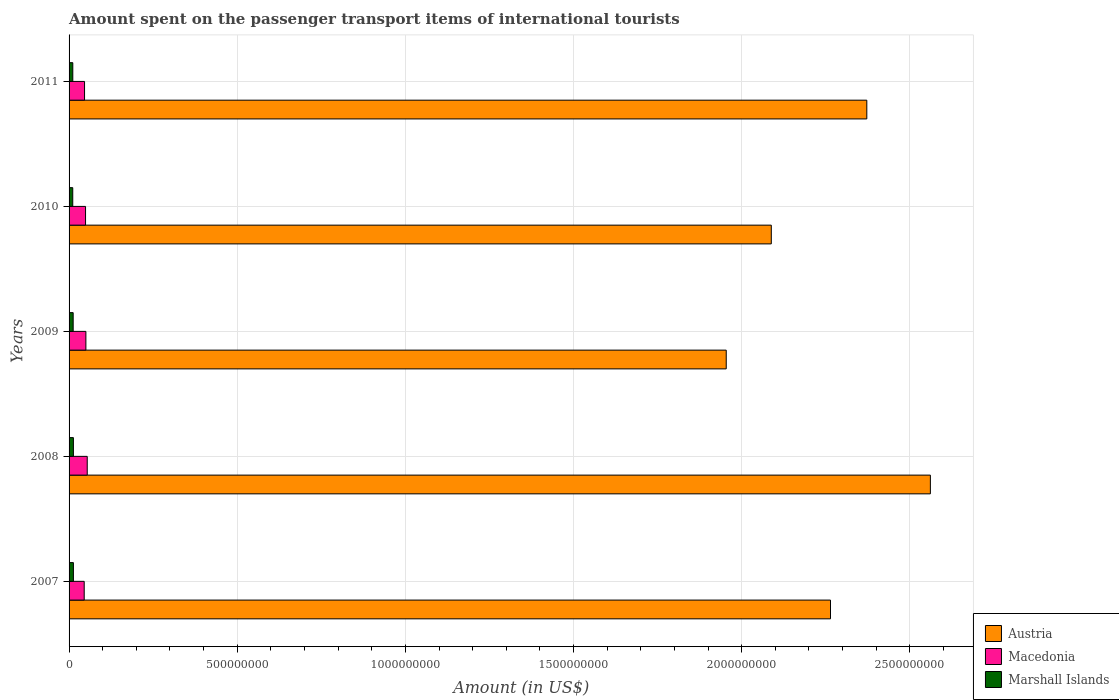How many different coloured bars are there?
Ensure brevity in your answer.  3. Are the number of bars per tick equal to the number of legend labels?
Your response must be concise. Yes. Are the number of bars on each tick of the Y-axis equal?
Make the answer very short. Yes. How many bars are there on the 1st tick from the top?
Make the answer very short. 3. How many bars are there on the 4th tick from the bottom?
Your answer should be compact. 3. What is the label of the 1st group of bars from the top?
Offer a terse response. 2011. What is the amount spent on the passenger transport items of international tourists in Macedonia in 2010?
Offer a very short reply. 4.90e+07. Across all years, what is the maximum amount spent on the passenger transport items of international tourists in Marshall Islands?
Offer a terse response. 1.29e+07. Across all years, what is the minimum amount spent on the passenger transport items of international tourists in Marshall Islands?
Offer a very short reply. 1.09e+07. In which year was the amount spent on the passenger transport items of international tourists in Macedonia maximum?
Provide a succinct answer. 2008. What is the total amount spent on the passenger transport items of international tourists in Austria in the graph?
Your answer should be very brief. 1.12e+1. What is the difference between the amount spent on the passenger transport items of international tourists in Austria in 2007 and that in 2011?
Your answer should be compact. -1.08e+08. What is the difference between the amount spent on the passenger transport items of international tourists in Austria in 2009 and the amount spent on the passenger transport items of international tourists in Macedonia in 2007?
Offer a terse response. 1.91e+09. What is the average amount spent on the passenger transport items of international tourists in Macedonia per year?
Provide a short and direct response. 4.88e+07. In the year 2011, what is the difference between the amount spent on the passenger transport items of international tourists in Macedonia and amount spent on the passenger transport items of international tourists in Marshall Islands?
Your answer should be compact. 3.49e+07. In how many years, is the amount spent on the passenger transport items of international tourists in Marshall Islands greater than 400000000 US$?
Ensure brevity in your answer.  0. What is the ratio of the amount spent on the passenger transport items of international tourists in Austria in 2007 to that in 2010?
Make the answer very short. 1.08. What is the difference between the highest and the second highest amount spent on the passenger transport items of international tourists in Austria?
Provide a succinct answer. 1.89e+08. What is the difference between the highest and the lowest amount spent on the passenger transport items of international tourists in Marshall Islands?
Your response must be concise. 1.97e+06. What does the 2nd bar from the top in 2007 represents?
Your answer should be very brief. Macedonia. What does the 1st bar from the bottom in 2011 represents?
Offer a very short reply. Austria. Is it the case that in every year, the sum of the amount spent on the passenger transport items of international tourists in Macedonia and amount spent on the passenger transport items of international tourists in Marshall Islands is greater than the amount spent on the passenger transport items of international tourists in Austria?
Ensure brevity in your answer.  No. How many bars are there?
Make the answer very short. 15. Are all the bars in the graph horizontal?
Provide a short and direct response. Yes. What is the difference between two consecutive major ticks on the X-axis?
Your response must be concise. 5.00e+08. Does the graph contain grids?
Ensure brevity in your answer.  Yes. How many legend labels are there?
Give a very brief answer. 3. What is the title of the graph?
Provide a succinct answer. Amount spent on the passenger transport items of international tourists. What is the label or title of the Y-axis?
Your answer should be very brief. Years. What is the Amount (in US$) in Austria in 2007?
Keep it short and to the point. 2.26e+09. What is the Amount (in US$) of Macedonia in 2007?
Ensure brevity in your answer.  4.50e+07. What is the Amount (in US$) of Marshall Islands in 2007?
Your answer should be compact. 1.29e+07. What is the Amount (in US$) of Austria in 2008?
Your answer should be very brief. 2.56e+09. What is the Amount (in US$) in Macedonia in 2008?
Your answer should be compact. 5.40e+07. What is the Amount (in US$) in Marshall Islands in 2008?
Offer a very short reply. 1.29e+07. What is the Amount (in US$) of Austria in 2009?
Keep it short and to the point. 1.95e+09. What is the Amount (in US$) of Macedonia in 2009?
Provide a succinct answer. 5.00e+07. What is the Amount (in US$) in Marshall Islands in 2009?
Provide a succinct answer. 1.22e+07. What is the Amount (in US$) in Austria in 2010?
Your response must be concise. 2.09e+09. What is the Amount (in US$) in Macedonia in 2010?
Give a very brief answer. 4.90e+07. What is the Amount (in US$) in Marshall Islands in 2010?
Keep it short and to the point. 1.09e+07. What is the Amount (in US$) of Austria in 2011?
Your response must be concise. 2.37e+09. What is the Amount (in US$) of Macedonia in 2011?
Make the answer very short. 4.60e+07. What is the Amount (in US$) of Marshall Islands in 2011?
Give a very brief answer. 1.11e+07. Across all years, what is the maximum Amount (in US$) in Austria?
Your answer should be very brief. 2.56e+09. Across all years, what is the maximum Amount (in US$) in Macedonia?
Make the answer very short. 5.40e+07. Across all years, what is the maximum Amount (in US$) of Marshall Islands?
Your response must be concise. 1.29e+07. Across all years, what is the minimum Amount (in US$) of Austria?
Give a very brief answer. 1.95e+09. Across all years, what is the minimum Amount (in US$) in Macedonia?
Keep it short and to the point. 4.50e+07. Across all years, what is the minimum Amount (in US$) of Marshall Islands?
Ensure brevity in your answer.  1.09e+07. What is the total Amount (in US$) of Austria in the graph?
Keep it short and to the point. 1.12e+1. What is the total Amount (in US$) of Macedonia in the graph?
Make the answer very short. 2.44e+08. What is the total Amount (in US$) of Marshall Islands in the graph?
Give a very brief answer. 6.00e+07. What is the difference between the Amount (in US$) of Austria in 2007 and that in 2008?
Your answer should be compact. -2.97e+08. What is the difference between the Amount (in US$) of Macedonia in 2007 and that in 2008?
Make the answer very short. -9.00e+06. What is the difference between the Amount (in US$) of Austria in 2007 and that in 2009?
Keep it short and to the point. 3.10e+08. What is the difference between the Amount (in US$) in Macedonia in 2007 and that in 2009?
Ensure brevity in your answer.  -5.00e+06. What is the difference between the Amount (in US$) of Austria in 2007 and that in 2010?
Provide a short and direct response. 1.76e+08. What is the difference between the Amount (in US$) of Macedonia in 2007 and that in 2010?
Keep it short and to the point. -4.00e+06. What is the difference between the Amount (in US$) of Marshall Islands in 2007 and that in 2010?
Your answer should be very brief. 1.97e+06. What is the difference between the Amount (in US$) of Austria in 2007 and that in 2011?
Your answer should be compact. -1.08e+08. What is the difference between the Amount (in US$) of Macedonia in 2007 and that in 2011?
Make the answer very short. -1.00e+06. What is the difference between the Amount (in US$) in Marshall Islands in 2007 and that in 2011?
Keep it short and to the point. 1.82e+06. What is the difference between the Amount (in US$) in Austria in 2008 and that in 2009?
Provide a succinct answer. 6.07e+08. What is the difference between the Amount (in US$) of Austria in 2008 and that in 2010?
Your response must be concise. 4.73e+08. What is the difference between the Amount (in US$) of Marshall Islands in 2008 and that in 2010?
Provide a short and direct response. 1.97e+06. What is the difference between the Amount (in US$) of Austria in 2008 and that in 2011?
Your answer should be very brief. 1.89e+08. What is the difference between the Amount (in US$) of Macedonia in 2008 and that in 2011?
Your answer should be very brief. 8.00e+06. What is the difference between the Amount (in US$) of Marshall Islands in 2008 and that in 2011?
Offer a terse response. 1.82e+06. What is the difference between the Amount (in US$) in Austria in 2009 and that in 2010?
Give a very brief answer. -1.34e+08. What is the difference between the Amount (in US$) in Marshall Islands in 2009 and that in 2010?
Offer a terse response. 1.27e+06. What is the difference between the Amount (in US$) in Austria in 2009 and that in 2011?
Your answer should be compact. -4.18e+08. What is the difference between the Amount (in US$) in Marshall Islands in 2009 and that in 2011?
Keep it short and to the point. 1.12e+06. What is the difference between the Amount (in US$) in Austria in 2010 and that in 2011?
Ensure brevity in your answer.  -2.84e+08. What is the difference between the Amount (in US$) of Macedonia in 2010 and that in 2011?
Ensure brevity in your answer.  3.00e+06. What is the difference between the Amount (in US$) in Marshall Islands in 2010 and that in 2011?
Your answer should be very brief. -1.50e+05. What is the difference between the Amount (in US$) of Austria in 2007 and the Amount (in US$) of Macedonia in 2008?
Offer a very short reply. 2.21e+09. What is the difference between the Amount (in US$) of Austria in 2007 and the Amount (in US$) of Marshall Islands in 2008?
Provide a short and direct response. 2.25e+09. What is the difference between the Amount (in US$) in Macedonia in 2007 and the Amount (in US$) in Marshall Islands in 2008?
Your answer should be very brief. 3.21e+07. What is the difference between the Amount (in US$) in Austria in 2007 and the Amount (in US$) in Macedonia in 2009?
Make the answer very short. 2.21e+09. What is the difference between the Amount (in US$) in Austria in 2007 and the Amount (in US$) in Marshall Islands in 2009?
Your answer should be compact. 2.25e+09. What is the difference between the Amount (in US$) of Macedonia in 2007 and the Amount (in US$) of Marshall Islands in 2009?
Your answer should be very brief. 3.28e+07. What is the difference between the Amount (in US$) in Austria in 2007 and the Amount (in US$) in Macedonia in 2010?
Make the answer very short. 2.22e+09. What is the difference between the Amount (in US$) of Austria in 2007 and the Amount (in US$) of Marshall Islands in 2010?
Your answer should be very brief. 2.25e+09. What is the difference between the Amount (in US$) in Macedonia in 2007 and the Amount (in US$) in Marshall Islands in 2010?
Your response must be concise. 3.41e+07. What is the difference between the Amount (in US$) of Austria in 2007 and the Amount (in US$) of Macedonia in 2011?
Your response must be concise. 2.22e+09. What is the difference between the Amount (in US$) in Austria in 2007 and the Amount (in US$) in Marshall Islands in 2011?
Offer a very short reply. 2.25e+09. What is the difference between the Amount (in US$) in Macedonia in 2007 and the Amount (in US$) in Marshall Islands in 2011?
Provide a short and direct response. 3.39e+07. What is the difference between the Amount (in US$) of Austria in 2008 and the Amount (in US$) of Macedonia in 2009?
Ensure brevity in your answer.  2.51e+09. What is the difference between the Amount (in US$) in Austria in 2008 and the Amount (in US$) in Marshall Islands in 2009?
Your answer should be compact. 2.55e+09. What is the difference between the Amount (in US$) of Macedonia in 2008 and the Amount (in US$) of Marshall Islands in 2009?
Your answer should be compact. 4.18e+07. What is the difference between the Amount (in US$) in Austria in 2008 and the Amount (in US$) in Macedonia in 2010?
Your answer should be compact. 2.51e+09. What is the difference between the Amount (in US$) in Austria in 2008 and the Amount (in US$) in Marshall Islands in 2010?
Offer a very short reply. 2.55e+09. What is the difference between the Amount (in US$) in Macedonia in 2008 and the Amount (in US$) in Marshall Islands in 2010?
Your answer should be compact. 4.31e+07. What is the difference between the Amount (in US$) in Austria in 2008 and the Amount (in US$) in Macedonia in 2011?
Your response must be concise. 2.52e+09. What is the difference between the Amount (in US$) of Austria in 2008 and the Amount (in US$) of Marshall Islands in 2011?
Give a very brief answer. 2.55e+09. What is the difference between the Amount (in US$) in Macedonia in 2008 and the Amount (in US$) in Marshall Islands in 2011?
Offer a terse response. 4.29e+07. What is the difference between the Amount (in US$) in Austria in 2009 and the Amount (in US$) in Macedonia in 2010?
Your answer should be very brief. 1.90e+09. What is the difference between the Amount (in US$) in Austria in 2009 and the Amount (in US$) in Marshall Islands in 2010?
Your answer should be very brief. 1.94e+09. What is the difference between the Amount (in US$) in Macedonia in 2009 and the Amount (in US$) in Marshall Islands in 2010?
Give a very brief answer. 3.91e+07. What is the difference between the Amount (in US$) of Austria in 2009 and the Amount (in US$) of Macedonia in 2011?
Give a very brief answer. 1.91e+09. What is the difference between the Amount (in US$) of Austria in 2009 and the Amount (in US$) of Marshall Islands in 2011?
Your response must be concise. 1.94e+09. What is the difference between the Amount (in US$) of Macedonia in 2009 and the Amount (in US$) of Marshall Islands in 2011?
Provide a short and direct response. 3.89e+07. What is the difference between the Amount (in US$) of Austria in 2010 and the Amount (in US$) of Macedonia in 2011?
Provide a short and direct response. 2.04e+09. What is the difference between the Amount (in US$) in Austria in 2010 and the Amount (in US$) in Marshall Islands in 2011?
Provide a short and direct response. 2.08e+09. What is the difference between the Amount (in US$) of Macedonia in 2010 and the Amount (in US$) of Marshall Islands in 2011?
Provide a short and direct response. 3.79e+07. What is the average Amount (in US$) in Austria per year?
Give a very brief answer. 2.25e+09. What is the average Amount (in US$) of Macedonia per year?
Ensure brevity in your answer.  4.88e+07. What is the average Amount (in US$) of Marshall Islands per year?
Your answer should be compact. 1.20e+07. In the year 2007, what is the difference between the Amount (in US$) of Austria and Amount (in US$) of Macedonia?
Your answer should be very brief. 2.22e+09. In the year 2007, what is the difference between the Amount (in US$) in Austria and Amount (in US$) in Marshall Islands?
Ensure brevity in your answer.  2.25e+09. In the year 2007, what is the difference between the Amount (in US$) of Macedonia and Amount (in US$) of Marshall Islands?
Ensure brevity in your answer.  3.21e+07. In the year 2008, what is the difference between the Amount (in US$) in Austria and Amount (in US$) in Macedonia?
Ensure brevity in your answer.  2.51e+09. In the year 2008, what is the difference between the Amount (in US$) of Austria and Amount (in US$) of Marshall Islands?
Provide a succinct answer. 2.55e+09. In the year 2008, what is the difference between the Amount (in US$) in Macedonia and Amount (in US$) in Marshall Islands?
Your response must be concise. 4.11e+07. In the year 2009, what is the difference between the Amount (in US$) in Austria and Amount (in US$) in Macedonia?
Provide a short and direct response. 1.90e+09. In the year 2009, what is the difference between the Amount (in US$) of Austria and Amount (in US$) of Marshall Islands?
Your answer should be compact. 1.94e+09. In the year 2009, what is the difference between the Amount (in US$) of Macedonia and Amount (in US$) of Marshall Islands?
Your response must be concise. 3.78e+07. In the year 2010, what is the difference between the Amount (in US$) of Austria and Amount (in US$) of Macedonia?
Your answer should be very brief. 2.04e+09. In the year 2010, what is the difference between the Amount (in US$) in Austria and Amount (in US$) in Marshall Islands?
Provide a succinct answer. 2.08e+09. In the year 2010, what is the difference between the Amount (in US$) of Macedonia and Amount (in US$) of Marshall Islands?
Ensure brevity in your answer.  3.81e+07. In the year 2011, what is the difference between the Amount (in US$) of Austria and Amount (in US$) of Macedonia?
Your response must be concise. 2.33e+09. In the year 2011, what is the difference between the Amount (in US$) in Austria and Amount (in US$) in Marshall Islands?
Your answer should be very brief. 2.36e+09. In the year 2011, what is the difference between the Amount (in US$) in Macedonia and Amount (in US$) in Marshall Islands?
Provide a succinct answer. 3.49e+07. What is the ratio of the Amount (in US$) in Austria in 2007 to that in 2008?
Ensure brevity in your answer.  0.88. What is the ratio of the Amount (in US$) in Macedonia in 2007 to that in 2008?
Provide a short and direct response. 0.83. What is the ratio of the Amount (in US$) of Marshall Islands in 2007 to that in 2008?
Make the answer very short. 1. What is the ratio of the Amount (in US$) of Austria in 2007 to that in 2009?
Your answer should be compact. 1.16. What is the ratio of the Amount (in US$) of Marshall Islands in 2007 to that in 2009?
Ensure brevity in your answer.  1.06. What is the ratio of the Amount (in US$) in Austria in 2007 to that in 2010?
Provide a short and direct response. 1.08. What is the ratio of the Amount (in US$) of Macedonia in 2007 to that in 2010?
Ensure brevity in your answer.  0.92. What is the ratio of the Amount (in US$) in Marshall Islands in 2007 to that in 2010?
Provide a short and direct response. 1.18. What is the ratio of the Amount (in US$) in Austria in 2007 to that in 2011?
Your answer should be compact. 0.95. What is the ratio of the Amount (in US$) of Macedonia in 2007 to that in 2011?
Make the answer very short. 0.98. What is the ratio of the Amount (in US$) in Marshall Islands in 2007 to that in 2011?
Keep it short and to the point. 1.16. What is the ratio of the Amount (in US$) of Austria in 2008 to that in 2009?
Keep it short and to the point. 1.31. What is the ratio of the Amount (in US$) in Macedonia in 2008 to that in 2009?
Your answer should be very brief. 1.08. What is the ratio of the Amount (in US$) in Marshall Islands in 2008 to that in 2009?
Make the answer very short. 1.06. What is the ratio of the Amount (in US$) in Austria in 2008 to that in 2010?
Provide a short and direct response. 1.23. What is the ratio of the Amount (in US$) of Macedonia in 2008 to that in 2010?
Make the answer very short. 1.1. What is the ratio of the Amount (in US$) in Marshall Islands in 2008 to that in 2010?
Provide a short and direct response. 1.18. What is the ratio of the Amount (in US$) of Austria in 2008 to that in 2011?
Offer a terse response. 1.08. What is the ratio of the Amount (in US$) of Macedonia in 2008 to that in 2011?
Offer a terse response. 1.17. What is the ratio of the Amount (in US$) of Marshall Islands in 2008 to that in 2011?
Offer a terse response. 1.16. What is the ratio of the Amount (in US$) of Austria in 2009 to that in 2010?
Offer a very short reply. 0.94. What is the ratio of the Amount (in US$) in Macedonia in 2009 to that in 2010?
Keep it short and to the point. 1.02. What is the ratio of the Amount (in US$) in Marshall Islands in 2009 to that in 2010?
Offer a very short reply. 1.12. What is the ratio of the Amount (in US$) in Austria in 2009 to that in 2011?
Keep it short and to the point. 0.82. What is the ratio of the Amount (in US$) of Macedonia in 2009 to that in 2011?
Your response must be concise. 1.09. What is the ratio of the Amount (in US$) of Marshall Islands in 2009 to that in 2011?
Your answer should be very brief. 1.1. What is the ratio of the Amount (in US$) of Austria in 2010 to that in 2011?
Keep it short and to the point. 0.88. What is the ratio of the Amount (in US$) of Macedonia in 2010 to that in 2011?
Provide a short and direct response. 1.07. What is the ratio of the Amount (in US$) of Marshall Islands in 2010 to that in 2011?
Keep it short and to the point. 0.99. What is the difference between the highest and the second highest Amount (in US$) in Austria?
Your answer should be very brief. 1.89e+08. What is the difference between the highest and the second highest Amount (in US$) of Marshall Islands?
Provide a short and direct response. 0. What is the difference between the highest and the lowest Amount (in US$) of Austria?
Make the answer very short. 6.07e+08. What is the difference between the highest and the lowest Amount (in US$) of Macedonia?
Keep it short and to the point. 9.00e+06. What is the difference between the highest and the lowest Amount (in US$) in Marshall Islands?
Ensure brevity in your answer.  1.97e+06. 